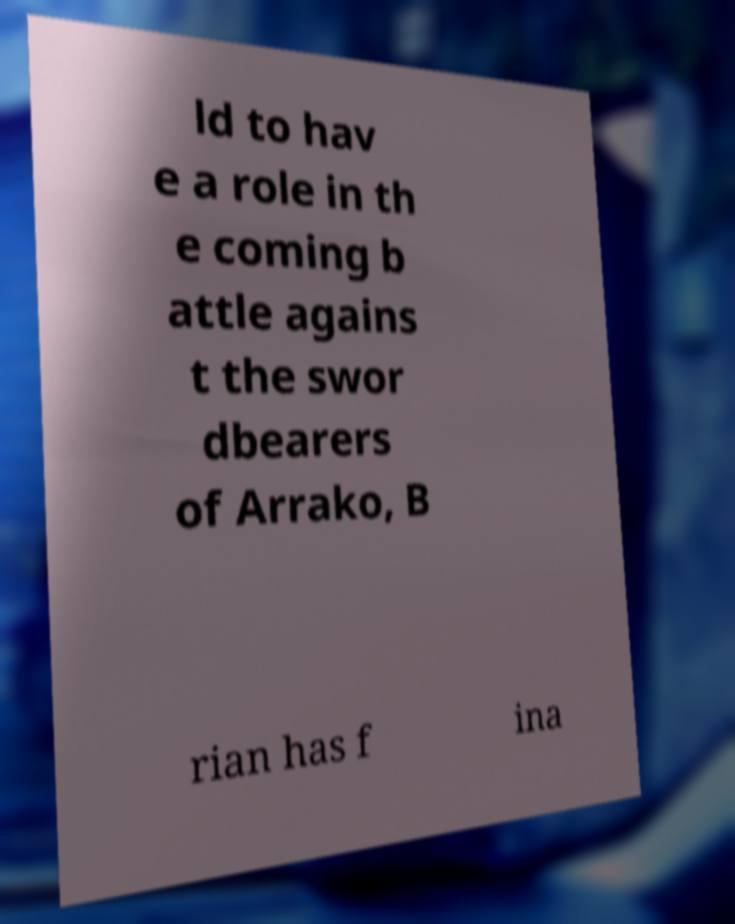Please identify and transcribe the text found in this image. ld to hav e a role in th e coming b attle agains t the swor dbearers of Arrako, B rian has f ina 